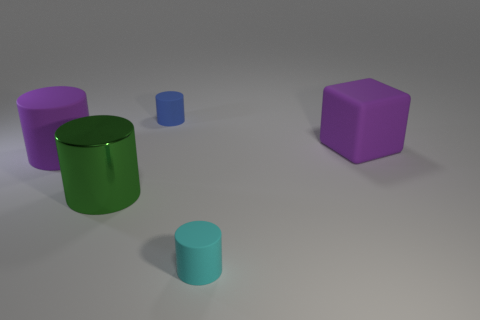What is the size of the object that is the same color as the big rubber cube?
Provide a succinct answer. Large. What number of large things are green metallic cylinders or rubber blocks?
Keep it short and to the point. 2. What number of small objects are in front of the large green metal cylinder and behind the large block?
Keep it short and to the point. 0. Does the blue cylinder have the same material as the purple object that is in front of the big purple rubber cube?
Keep it short and to the point. Yes. How many yellow objects are either metal cylinders or big matte cubes?
Your response must be concise. 0. Is there a gray matte object of the same size as the cyan matte thing?
Make the answer very short. No. The small thing to the right of the tiny rubber cylinder to the left of the tiny rubber cylinder that is in front of the blue matte cylinder is made of what material?
Ensure brevity in your answer.  Rubber. Is the number of rubber cubes behind the large purple cube the same as the number of small blue cylinders?
Your answer should be compact. No. Are the tiny cylinder that is in front of the metal cylinder and the large purple object left of the green shiny cylinder made of the same material?
Make the answer very short. Yes. How many things are tiny brown metal balls or big purple matte objects in front of the purple cube?
Make the answer very short. 1. 